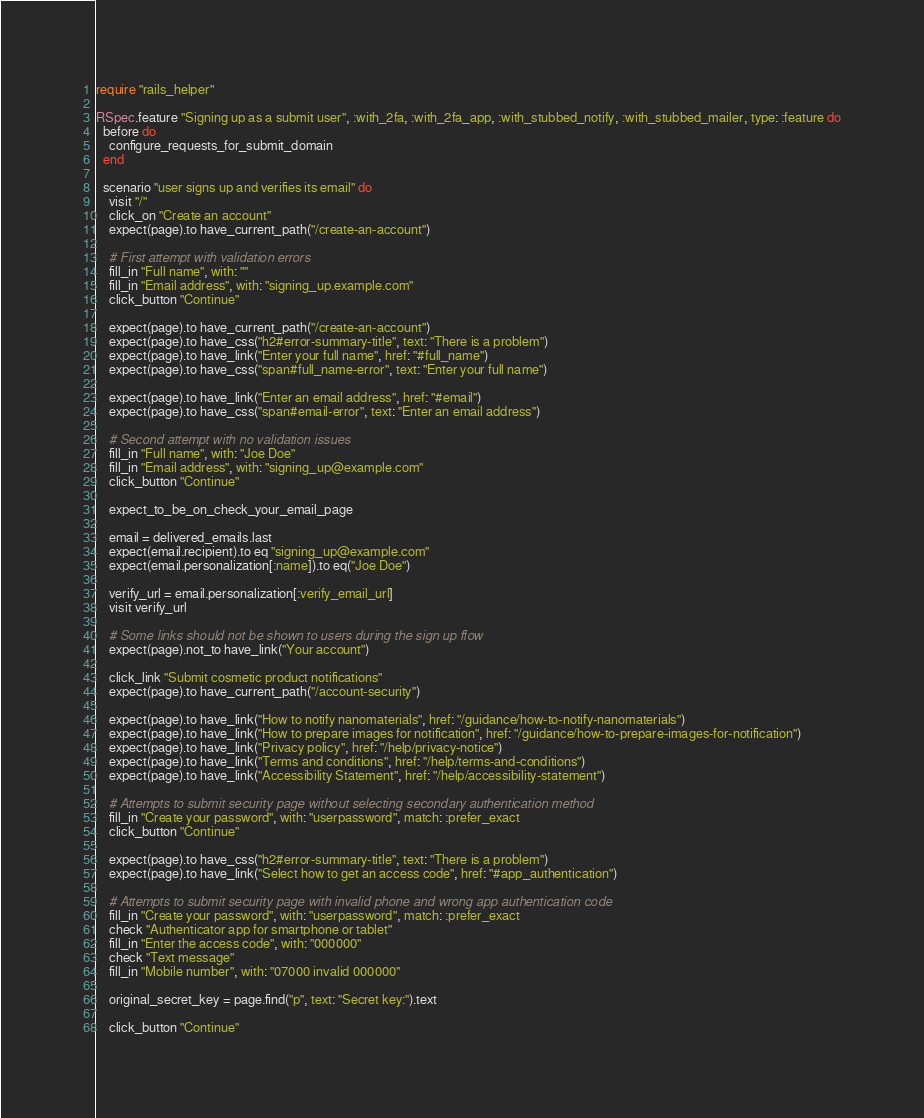<code> <loc_0><loc_0><loc_500><loc_500><_Ruby_>require "rails_helper"

RSpec.feature "Signing up as a submit user", :with_2fa, :with_2fa_app, :with_stubbed_notify, :with_stubbed_mailer, type: :feature do
  before do
    configure_requests_for_submit_domain
  end

  scenario "user signs up and verifies its email" do
    visit "/"
    click_on "Create an account"
    expect(page).to have_current_path("/create-an-account")

    # First attempt with validation errors
    fill_in "Full name", with: ""
    fill_in "Email address", with: "signing_up.example.com"
    click_button "Continue"

    expect(page).to have_current_path("/create-an-account")
    expect(page).to have_css("h2#error-summary-title", text: "There is a problem")
    expect(page).to have_link("Enter your full name", href: "#full_name")
    expect(page).to have_css("span#full_name-error", text: "Enter your full name")

    expect(page).to have_link("Enter an email address", href: "#email")
    expect(page).to have_css("span#email-error", text: "Enter an email address")

    # Second attempt with no validation issues
    fill_in "Full name", with: "Joe Doe"
    fill_in "Email address", with: "signing_up@example.com"
    click_button "Continue"

    expect_to_be_on_check_your_email_page

    email = delivered_emails.last
    expect(email.recipient).to eq "signing_up@example.com"
    expect(email.personalization[:name]).to eq("Joe Doe")

    verify_url = email.personalization[:verify_email_url]
    visit verify_url

    # Some links should not be shown to users during the sign up flow
    expect(page).not_to have_link("Your account")

    click_link "Submit cosmetic product notifications"
    expect(page).to have_current_path("/account-security")

    expect(page).to have_link("How to notify nanomaterials", href: "/guidance/how-to-notify-nanomaterials")
    expect(page).to have_link("How to prepare images for notification", href: "/guidance/how-to-prepare-images-for-notification")
    expect(page).to have_link("Privacy policy", href: "/help/privacy-notice")
    expect(page).to have_link("Terms and conditions", href: "/help/terms-and-conditions")
    expect(page).to have_link("Accessibility Statement", href: "/help/accessibility-statement")

    # Attempts to submit security page without selecting secondary authentication method
    fill_in "Create your password", with: "userpassword", match: :prefer_exact
    click_button "Continue"

    expect(page).to have_css("h2#error-summary-title", text: "There is a problem")
    expect(page).to have_link("Select how to get an access code", href: "#app_authentication")

    # Attempts to submit security page with invalid phone and wrong app authentication code
    fill_in "Create your password", with: "userpassword", match: :prefer_exact
    check "Authenticator app for smartphone or tablet"
    fill_in "Enter the access code", with: "000000"
    check "Text message"
    fill_in "Mobile number", with: "07000 invalid 000000"

    original_secret_key = page.find("p", text: "Secret key:").text

    click_button "Continue"
</code> 